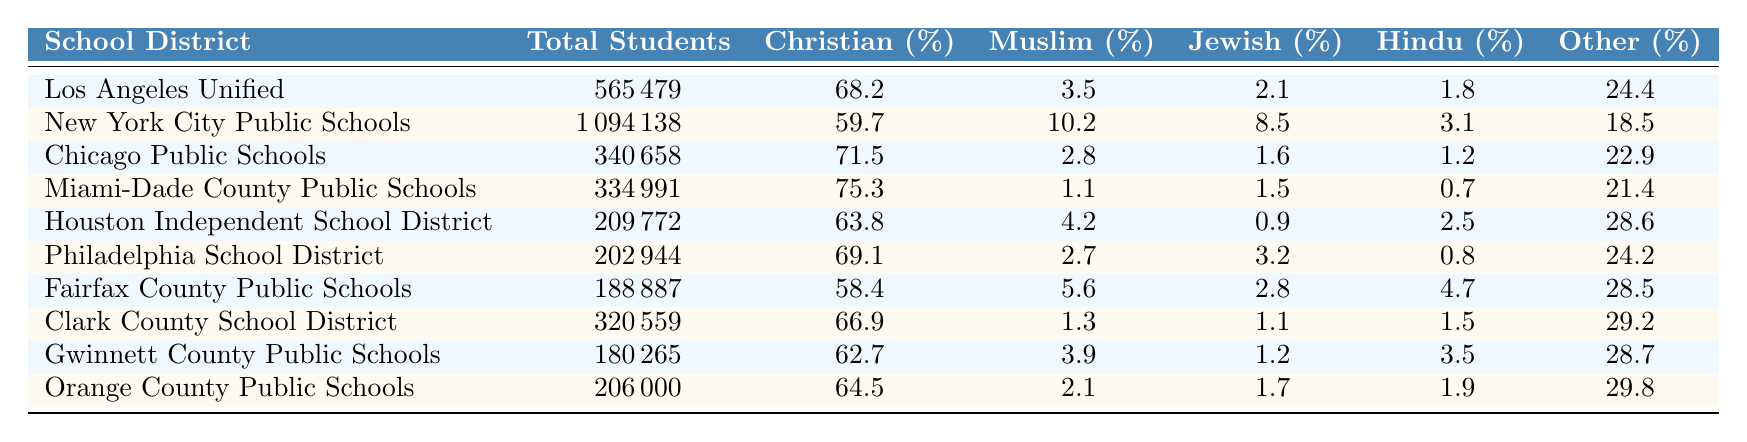What is the total number of students enrolled in New York City Public Schools? The data shows that the total number of students in New York City Public Schools is listed under the "Total Students" column. That value is 1,094,138.
Answer: 1,094,138 Which school district has the highest percentage of Hindu students? To find this, we compare the "Hindu (%)" values across all school districts. Miami-Dade County Public Schools has the highest percentage at 0.7%.
Answer: Miami-Dade County Public Schools What percentage of students in the Chicago Public Schools are religious minorities? To determine this, we sum the percentages of Muslim, Jewish, Hindu, and Other students. Therefore, we calculate 2.8% (Muslim) + 1.6% (Jewish) + 1.2% (Hindu) + 22.9% (Other) = 28.5%.
Answer: 28.5% Is the percentage of Muslim students higher in Los Angeles Unified than in Philadelphia School District? We can directly compare the "Muslim (%)" values from both districts. Los Angeles Unified has 3.5% and Philadelphia has 2.7%. Since 3.5% is greater than 2.7%, the answer is yes.
Answer: Yes What is the average percentage of Muslim students across all school districts? To calculate the average, we find the sum of the Muslim percentages from each district: 3.5 + 10.2 + 2.8 + 1.1 + 4.2 + 2.7 + 5.6 + 1.3 + 3.9 + 2.1 = 32.4. There are 10 school districts, so we divide 32.4 by 10 to get the average: 32.4 / 10 = 3.24%.
Answer: 3.24% Which school district has the largest total number of students? The maximum total students can be identified by checking the "Total Students" values. New York City Public Schools has 1,094,138, which is the highest.
Answer: New York City Public Schools 